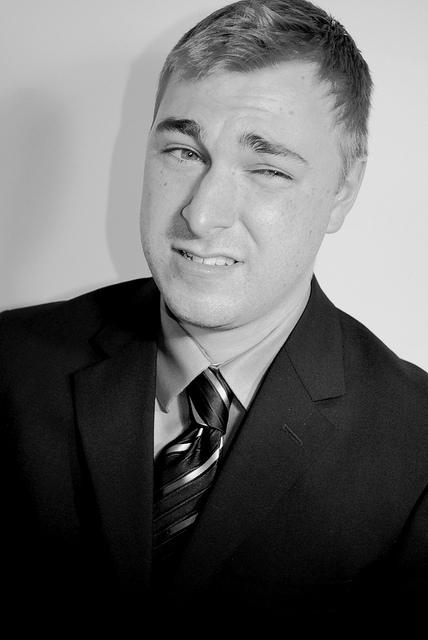Is the man wearing a French cut shirt?
Write a very short answer. No. Does his tie and shirt match?
Quick response, please. Yes. Is his hair long?
Give a very brief answer. No. What pattern is his tie?
Answer briefly. Striped. What color tie is the man wearing?
Concise answer only. Black. Is the man going to sneeze?
Write a very short answer. No. Who is wearing a necktie?
Short answer required. Man. Is the man winking?
Concise answer only. No. Could this be a groom?
Keep it brief. Yes. Is this a color photo?
Quick response, please. No. 